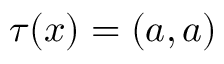<formula> <loc_0><loc_0><loc_500><loc_500>\tau ( x ) = ( a , a )</formula> 